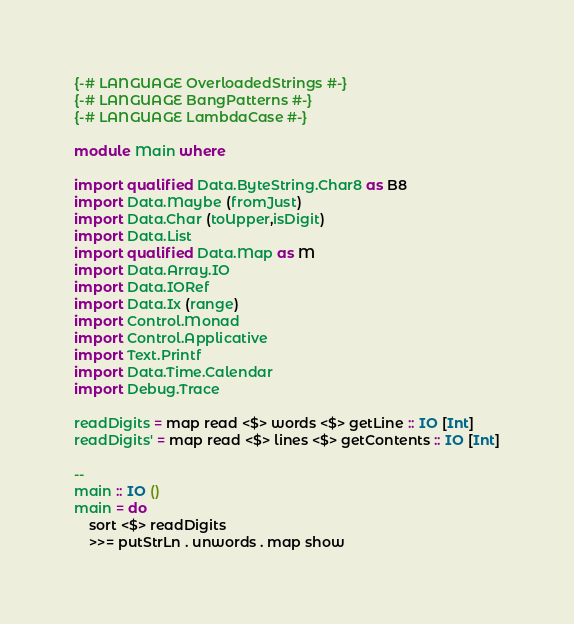<code> <loc_0><loc_0><loc_500><loc_500><_Haskell_>{-# LANGUAGE OverloadedStrings #-}
{-# LANGUAGE BangPatterns #-}
{-# LANGUAGE LambdaCase #-}

module Main where

import qualified Data.ByteString.Char8 as B8
import Data.Maybe (fromJust)
import Data.Char (toUpper,isDigit)
import Data.List
import qualified Data.Map as M
import Data.Array.IO
import Data.IORef
import Data.Ix (range)
import Control.Monad
import Control.Applicative
import Text.Printf
import Data.Time.Calendar
import Debug.Trace

readDigits = map read <$> words <$> getLine :: IO [Int]
readDigits' = map read <$> lines <$> getContents :: IO [Int]

--
main :: IO ()
main = do
    sort <$> readDigits
    >>= putStrLn . unwords . map show </code> 